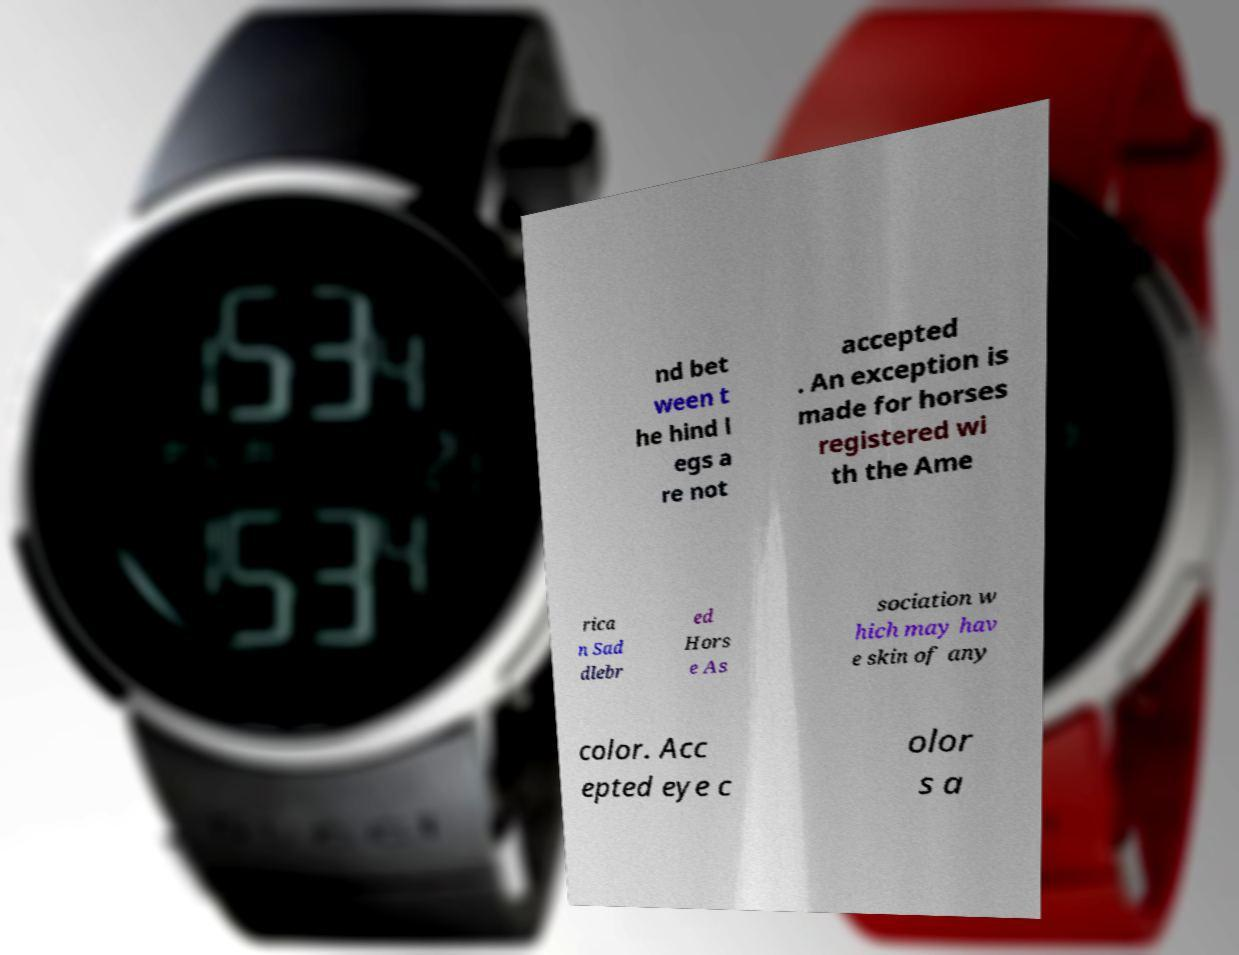For documentation purposes, I need the text within this image transcribed. Could you provide that? nd bet ween t he hind l egs a re not accepted . An exception is made for horses registered wi th the Ame rica n Sad dlebr ed Hors e As sociation w hich may hav e skin of any color. Acc epted eye c olor s a 